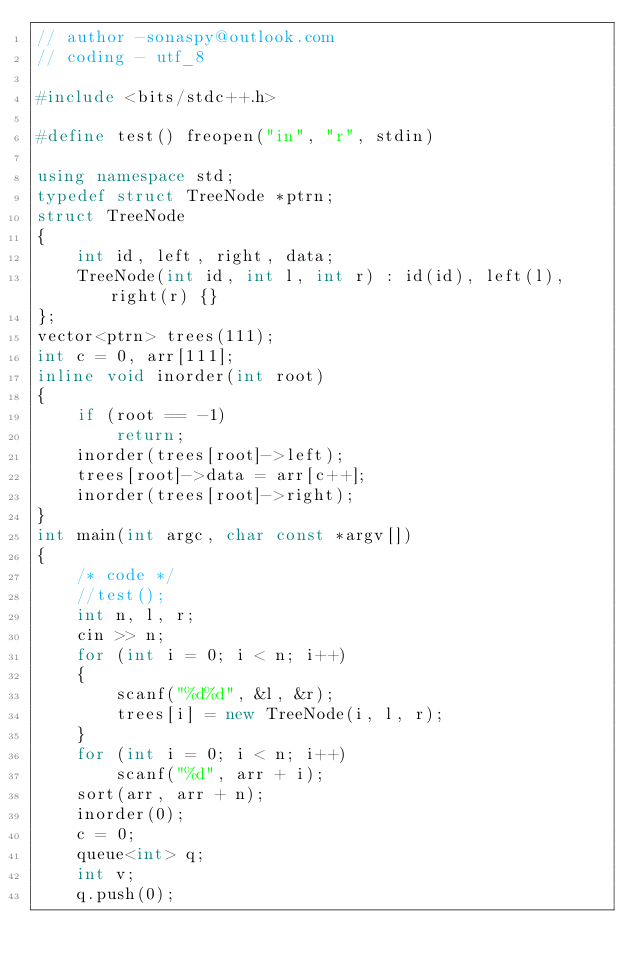<code> <loc_0><loc_0><loc_500><loc_500><_C++_>// author -sonaspy@outlook.com
// coding - utf_8

#include <bits/stdc++.h>

#define test() freopen("in", "r", stdin)

using namespace std;
typedef struct TreeNode *ptrn;
struct TreeNode
{
    int id, left, right, data;
    TreeNode(int id, int l, int r) : id(id), left(l), right(r) {}
};
vector<ptrn> trees(111);
int c = 0, arr[111];
inline void inorder(int root)
{
    if (root == -1)
        return;
    inorder(trees[root]->left);
    trees[root]->data = arr[c++];
    inorder(trees[root]->right);
}
int main(int argc, char const *argv[])
{
    /* code */
    //test();
    int n, l, r;
    cin >> n;
    for (int i = 0; i < n; i++)
    {
        scanf("%d%d", &l, &r);
        trees[i] = new TreeNode(i, l, r);
    }
    for (int i = 0; i < n; i++)
        scanf("%d", arr + i);
    sort(arr, arr + n);
    inorder(0);
    c = 0;
    queue<int> q;
    int v;
    q.push(0);</code> 